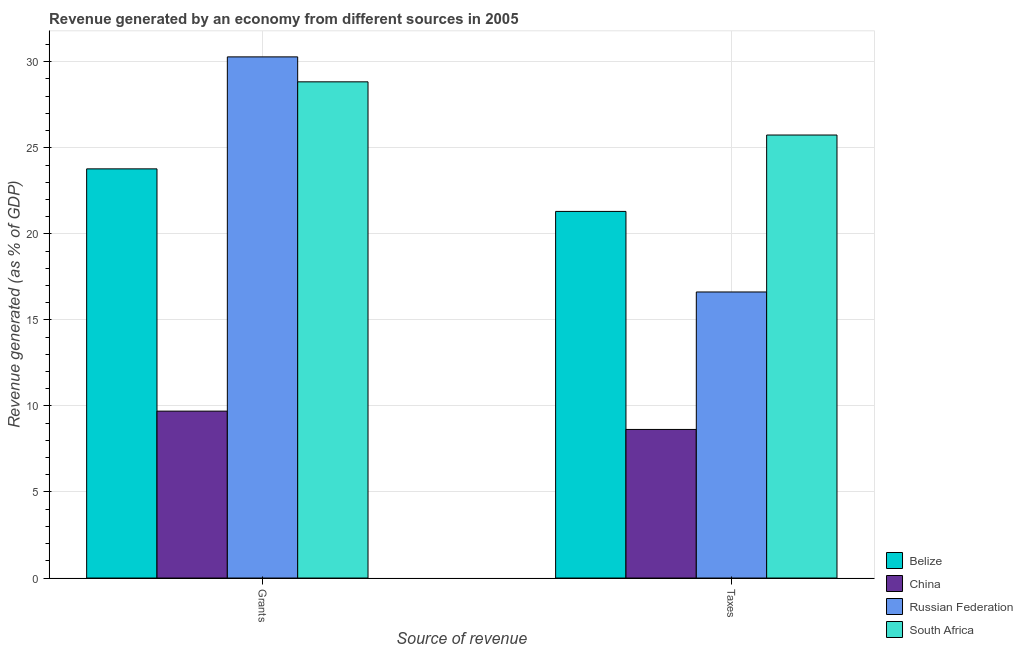How many different coloured bars are there?
Provide a succinct answer. 4. Are the number of bars per tick equal to the number of legend labels?
Offer a very short reply. Yes. How many bars are there on the 1st tick from the right?
Your answer should be very brief. 4. What is the label of the 2nd group of bars from the left?
Your answer should be compact. Taxes. What is the revenue generated by grants in South Africa?
Your answer should be very brief. 28.83. Across all countries, what is the maximum revenue generated by taxes?
Provide a succinct answer. 25.74. Across all countries, what is the minimum revenue generated by grants?
Your response must be concise. 9.7. In which country was the revenue generated by grants maximum?
Ensure brevity in your answer.  Russian Federation. In which country was the revenue generated by grants minimum?
Your answer should be compact. China. What is the total revenue generated by taxes in the graph?
Provide a short and direct response. 72.31. What is the difference between the revenue generated by grants in South Africa and that in Belize?
Keep it short and to the point. 5.06. What is the difference between the revenue generated by taxes in China and the revenue generated by grants in South Africa?
Make the answer very short. -20.2. What is the average revenue generated by grants per country?
Your response must be concise. 23.15. What is the difference between the revenue generated by taxes and revenue generated by grants in Belize?
Your answer should be very brief. -2.47. In how many countries, is the revenue generated by grants greater than 17 %?
Your response must be concise. 3. What is the ratio of the revenue generated by taxes in Russian Federation to that in Belize?
Your answer should be very brief. 0.78. Is the revenue generated by taxes in South Africa less than that in Russian Federation?
Make the answer very short. No. What does the 3rd bar from the left in Grants represents?
Offer a terse response. Russian Federation. What does the 4th bar from the right in Grants represents?
Keep it short and to the point. Belize. How many bars are there?
Offer a terse response. 8. How many countries are there in the graph?
Give a very brief answer. 4. Are the values on the major ticks of Y-axis written in scientific E-notation?
Give a very brief answer. No. Does the graph contain any zero values?
Offer a terse response. No. Where does the legend appear in the graph?
Provide a short and direct response. Bottom right. How many legend labels are there?
Keep it short and to the point. 4. What is the title of the graph?
Ensure brevity in your answer.  Revenue generated by an economy from different sources in 2005. What is the label or title of the X-axis?
Provide a short and direct response. Source of revenue. What is the label or title of the Y-axis?
Provide a succinct answer. Revenue generated (as % of GDP). What is the Revenue generated (as % of GDP) of Belize in Grants?
Your response must be concise. 23.78. What is the Revenue generated (as % of GDP) of China in Grants?
Your answer should be compact. 9.7. What is the Revenue generated (as % of GDP) in Russian Federation in Grants?
Ensure brevity in your answer.  30.28. What is the Revenue generated (as % of GDP) of South Africa in Grants?
Make the answer very short. 28.83. What is the Revenue generated (as % of GDP) of Belize in Taxes?
Make the answer very short. 21.3. What is the Revenue generated (as % of GDP) of China in Taxes?
Offer a very short reply. 8.63. What is the Revenue generated (as % of GDP) in Russian Federation in Taxes?
Give a very brief answer. 16.62. What is the Revenue generated (as % of GDP) in South Africa in Taxes?
Ensure brevity in your answer.  25.74. Across all Source of revenue, what is the maximum Revenue generated (as % of GDP) in Belize?
Offer a terse response. 23.78. Across all Source of revenue, what is the maximum Revenue generated (as % of GDP) in China?
Give a very brief answer. 9.7. Across all Source of revenue, what is the maximum Revenue generated (as % of GDP) of Russian Federation?
Provide a succinct answer. 30.28. Across all Source of revenue, what is the maximum Revenue generated (as % of GDP) in South Africa?
Your answer should be very brief. 28.83. Across all Source of revenue, what is the minimum Revenue generated (as % of GDP) in Belize?
Make the answer very short. 21.3. Across all Source of revenue, what is the minimum Revenue generated (as % of GDP) in China?
Offer a very short reply. 8.63. Across all Source of revenue, what is the minimum Revenue generated (as % of GDP) in Russian Federation?
Provide a short and direct response. 16.62. Across all Source of revenue, what is the minimum Revenue generated (as % of GDP) in South Africa?
Your response must be concise. 25.74. What is the total Revenue generated (as % of GDP) of Belize in the graph?
Provide a short and direct response. 45.08. What is the total Revenue generated (as % of GDP) of China in the graph?
Make the answer very short. 18.33. What is the total Revenue generated (as % of GDP) of Russian Federation in the graph?
Provide a short and direct response. 46.91. What is the total Revenue generated (as % of GDP) of South Africa in the graph?
Ensure brevity in your answer.  54.58. What is the difference between the Revenue generated (as % of GDP) in Belize in Grants and that in Taxes?
Provide a succinct answer. 2.47. What is the difference between the Revenue generated (as % of GDP) in China in Grants and that in Taxes?
Your answer should be very brief. 1.06. What is the difference between the Revenue generated (as % of GDP) in Russian Federation in Grants and that in Taxes?
Your answer should be compact. 13.66. What is the difference between the Revenue generated (as % of GDP) of South Africa in Grants and that in Taxes?
Provide a short and direct response. 3.09. What is the difference between the Revenue generated (as % of GDP) in Belize in Grants and the Revenue generated (as % of GDP) in China in Taxes?
Offer a terse response. 15.14. What is the difference between the Revenue generated (as % of GDP) in Belize in Grants and the Revenue generated (as % of GDP) in Russian Federation in Taxes?
Keep it short and to the point. 7.15. What is the difference between the Revenue generated (as % of GDP) of Belize in Grants and the Revenue generated (as % of GDP) of South Africa in Taxes?
Your answer should be very brief. -1.97. What is the difference between the Revenue generated (as % of GDP) in China in Grants and the Revenue generated (as % of GDP) in Russian Federation in Taxes?
Your answer should be compact. -6.92. What is the difference between the Revenue generated (as % of GDP) of China in Grants and the Revenue generated (as % of GDP) of South Africa in Taxes?
Ensure brevity in your answer.  -16.04. What is the difference between the Revenue generated (as % of GDP) of Russian Federation in Grants and the Revenue generated (as % of GDP) of South Africa in Taxes?
Ensure brevity in your answer.  4.54. What is the average Revenue generated (as % of GDP) of Belize per Source of revenue?
Provide a succinct answer. 22.54. What is the average Revenue generated (as % of GDP) of China per Source of revenue?
Offer a terse response. 9.17. What is the average Revenue generated (as % of GDP) of Russian Federation per Source of revenue?
Keep it short and to the point. 23.45. What is the average Revenue generated (as % of GDP) of South Africa per Source of revenue?
Your response must be concise. 27.29. What is the difference between the Revenue generated (as % of GDP) of Belize and Revenue generated (as % of GDP) of China in Grants?
Keep it short and to the point. 14.08. What is the difference between the Revenue generated (as % of GDP) of Belize and Revenue generated (as % of GDP) of Russian Federation in Grants?
Your answer should be very brief. -6.51. What is the difference between the Revenue generated (as % of GDP) of Belize and Revenue generated (as % of GDP) of South Africa in Grants?
Your answer should be very brief. -5.06. What is the difference between the Revenue generated (as % of GDP) in China and Revenue generated (as % of GDP) in Russian Federation in Grants?
Provide a succinct answer. -20.59. What is the difference between the Revenue generated (as % of GDP) of China and Revenue generated (as % of GDP) of South Africa in Grants?
Make the answer very short. -19.14. What is the difference between the Revenue generated (as % of GDP) of Russian Federation and Revenue generated (as % of GDP) of South Africa in Grants?
Keep it short and to the point. 1.45. What is the difference between the Revenue generated (as % of GDP) of Belize and Revenue generated (as % of GDP) of China in Taxes?
Keep it short and to the point. 12.67. What is the difference between the Revenue generated (as % of GDP) of Belize and Revenue generated (as % of GDP) of Russian Federation in Taxes?
Provide a short and direct response. 4.68. What is the difference between the Revenue generated (as % of GDP) in Belize and Revenue generated (as % of GDP) in South Africa in Taxes?
Offer a very short reply. -4.44. What is the difference between the Revenue generated (as % of GDP) of China and Revenue generated (as % of GDP) of Russian Federation in Taxes?
Your answer should be compact. -7.99. What is the difference between the Revenue generated (as % of GDP) in China and Revenue generated (as % of GDP) in South Africa in Taxes?
Give a very brief answer. -17.11. What is the difference between the Revenue generated (as % of GDP) in Russian Federation and Revenue generated (as % of GDP) in South Africa in Taxes?
Offer a terse response. -9.12. What is the ratio of the Revenue generated (as % of GDP) in Belize in Grants to that in Taxes?
Your response must be concise. 1.12. What is the ratio of the Revenue generated (as % of GDP) in China in Grants to that in Taxes?
Ensure brevity in your answer.  1.12. What is the ratio of the Revenue generated (as % of GDP) in Russian Federation in Grants to that in Taxes?
Give a very brief answer. 1.82. What is the ratio of the Revenue generated (as % of GDP) of South Africa in Grants to that in Taxes?
Your answer should be compact. 1.12. What is the difference between the highest and the second highest Revenue generated (as % of GDP) of Belize?
Offer a very short reply. 2.47. What is the difference between the highest and the second highest Revenue generated (as % of GDP) in China?
Make the answer very short. 1.06. What is the difference between the highest and the second highest Revenue generated (as % of GDP) of Russian Federation?
Your answer should be compact. 13.66. What is the difference between the highest and the second highest Revenue generated (as % of GDP) of South Africa?
Your response must be concise. 3.09. What is the difference between the highest and the lowest Revenue generated (as % of GDP) in Belize?
Keep it short and to the point. 2.47. What is the difference between the highest and the lowest Revenue generated (as % of GDP) of China?
Offer a terse response. 1.06. What is the difference between the highest and the lowest Revenue generated (as % of GDP) of Russian Federation?
Ensure brevity in your answer.  13.66. What is the difference between the highest and the lowest Revenue generated (as % of GDP) in South Africa?
Your answer should be very brief. 3.09. 